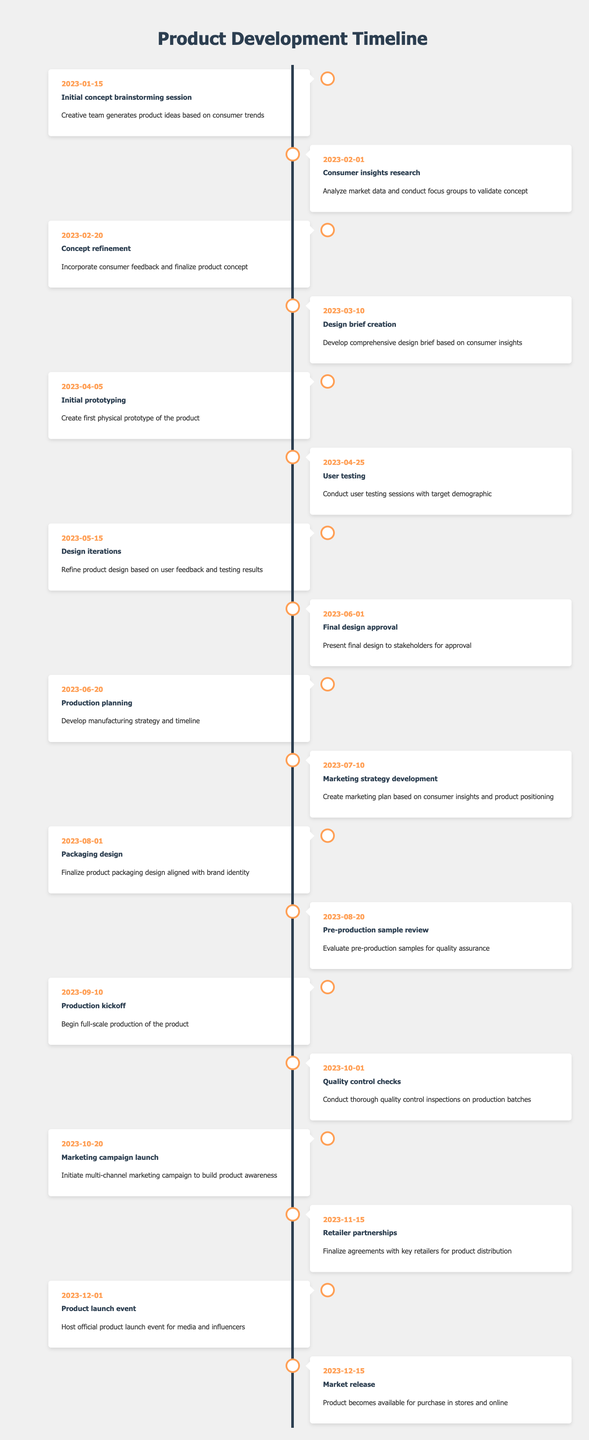What is the date of the initial concept brainstorming session? The initial concept brainstorming session is listed as the first milestone in the timeline with the date of 2023-01-15.
Answer: 2023-01-15 What milestone comes immediately after the consumer insights research? The consumer insights research is dated 2023-02-01, and the next milestone listed after that is the concept refinement on 2023-02-20.
Answer: Concept refinement Is there user testing scheduled before the initial prototyping? Yes, the user testing is scheduled for 2023-04-25, which comes after the initial prototyping dated 2023-04-05. Thus, it is not scheduled before it.
Answer: No How many days are there between the production kickoff and the marketing campaign launch? The production kickoff is on 2023-09-10 and the marketing campaign launch is on 2023-10-20. The difference is 10 days (October 20) - (September 10) = 10 days.
Answer: 40 days Which milestone has the longest gap from the previous milestone? By examining the timeline, the longest gap is between the marketing strategy development on 2023-07-10 and the packaging design on 2023-08-01, which is a gap of 22 days.
Answer: Marketing strategy development Are there any consumer insights related activities after the initial concept brainstorming session? Yes, after the initial concept brainstorming session on 2023-01-15, there are consumer insights research and concept refinement scheduled on 2023-02-01 and 2023-02-20 respectively.
Answer: Yes What is the total number of milestones from concept to launch? The timeline provides a total of 15 milestones starting from the initial concept brainstorming session up to the market release milestone, indicating a comprehensive product development plan.
Answer: 15 How many milestones involve direct consumer feedback? Direct consumer feedback is involved in the consumer insights research, concept refinement, and user testing milestones, totaling three milestones.
Answer: 3 When is the product launch event scheduled relative to the final design approval? The final design approval occurs on 2023-06-01, while the product launch event is planned for 2023-12-01, which indicates a span of 6 months between these two milestones.
Answer: 6 months 